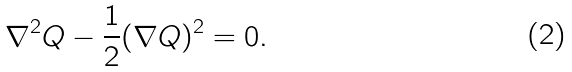<formula> <loc_0><loc_0><loc_500><loc_500>\nabla ^ { 2 } Q - \frac { 1 } { 2 } ( \nabla Q ) ^ { 2 } = 0 .</formula> 